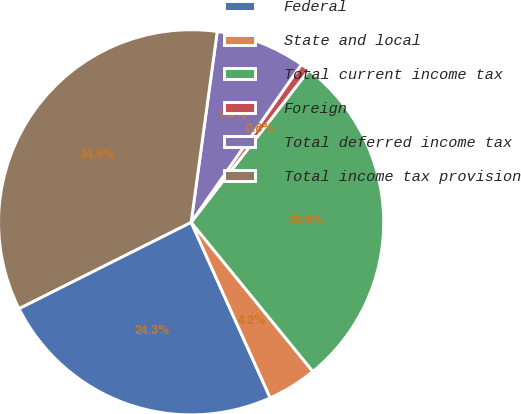Convert chart. <chart><loc_0><loc_0><loc_500><loc_500><pie_chart><fcel>Federal<fcel>State and local<fcel>Total current income tax<fcel>Foreign<fcel>Total deferred income tax<fcel>Total income tax provision<nl><fcel>24.34%<fcel>4.16%<fcel>28.62%<fcel>0.78%<fcel>7.54%<fcel>34.56%<nl></chart> 